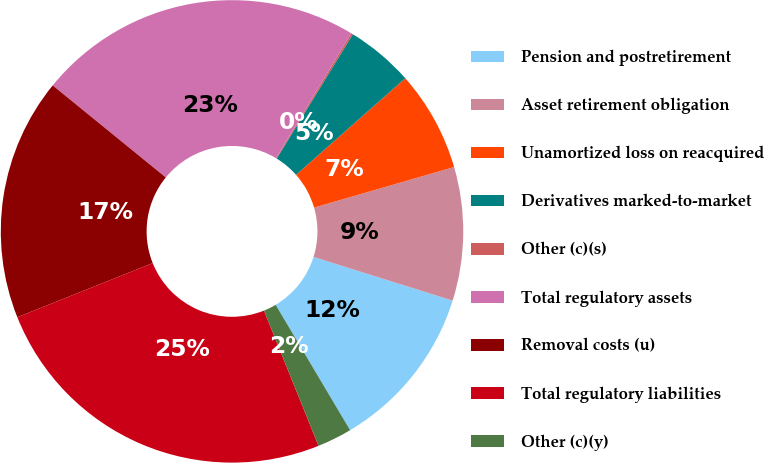Convert chart to OTSL. <chart><loc_0><loc_0><loc_500><loc_500><pie_chart><fcel>Pension and postretirement<fcel>Asset retirement obligation<fcel>Unamortized loss on reacquired<fcel>Derivatives marked-to-market<fcel>Other (c)(s)<fcel>Total regulatory assets<fcel>Removal costs (u)<fcel>Total regulatory liabilities<fcel>Other (c)(y)<nl><fcel>11.63%<fcel>9.33%<fcel>7.03%<fcel>4.73%<fcel>0.13%<fcel>22.75%<fcel>16.93%<fcel>25.05%<fcel>2.43%<nl></chart> 